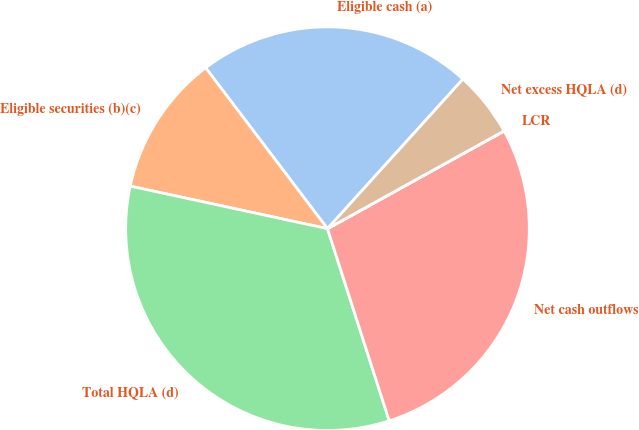Convert chart. <chart><loc_0><loc_0><loc_500><loc_500><pie_chart><fcel>Eligible cash (a)<fcel>Eligible securities (b)(c)<fcel>Total HQLA (d)<fcel>Net cash outflows<fcel>LCR<fcel>Net excess HQLA (d)<nl><fcel>22.03%<fcel>11.3%<fcel>33.33%<fcel>28.09%<fcel>0.01%<fcel>5.24%<nl></chart> 